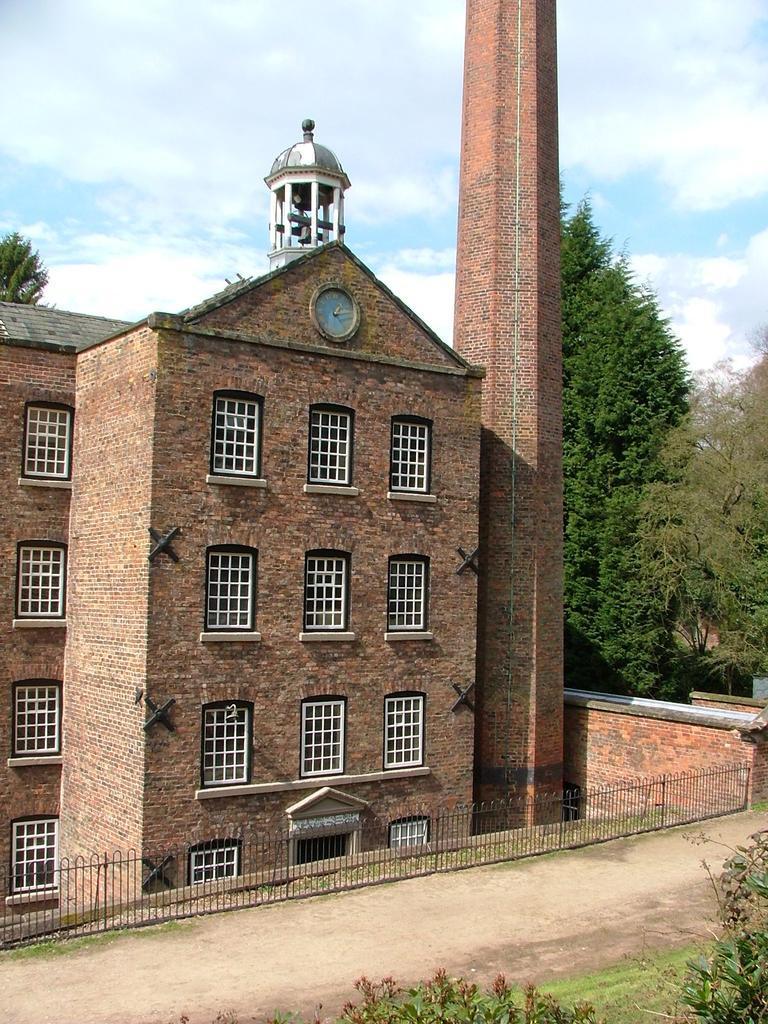Please provide a concise description of this image. In this picture we can see few buildings, trees, fence, clouds and a tower, and also we can see a clock. 